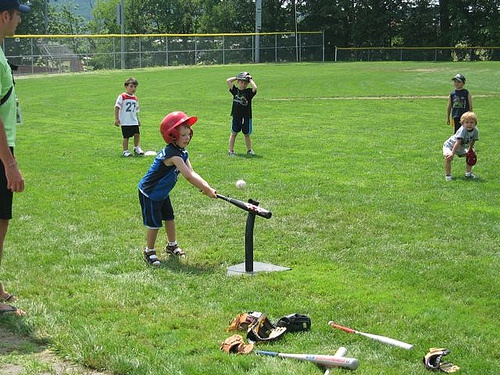Describe the objects in this image and their specific colors. I can see people in black, olive, and navy tones, people in black, gray, and green tones, people in black, gray, olive, and darkgreen tones, people in black, darkgray, gray, and lightblue tones, and people in black, gray, white, and darkgreen tones in this image. 